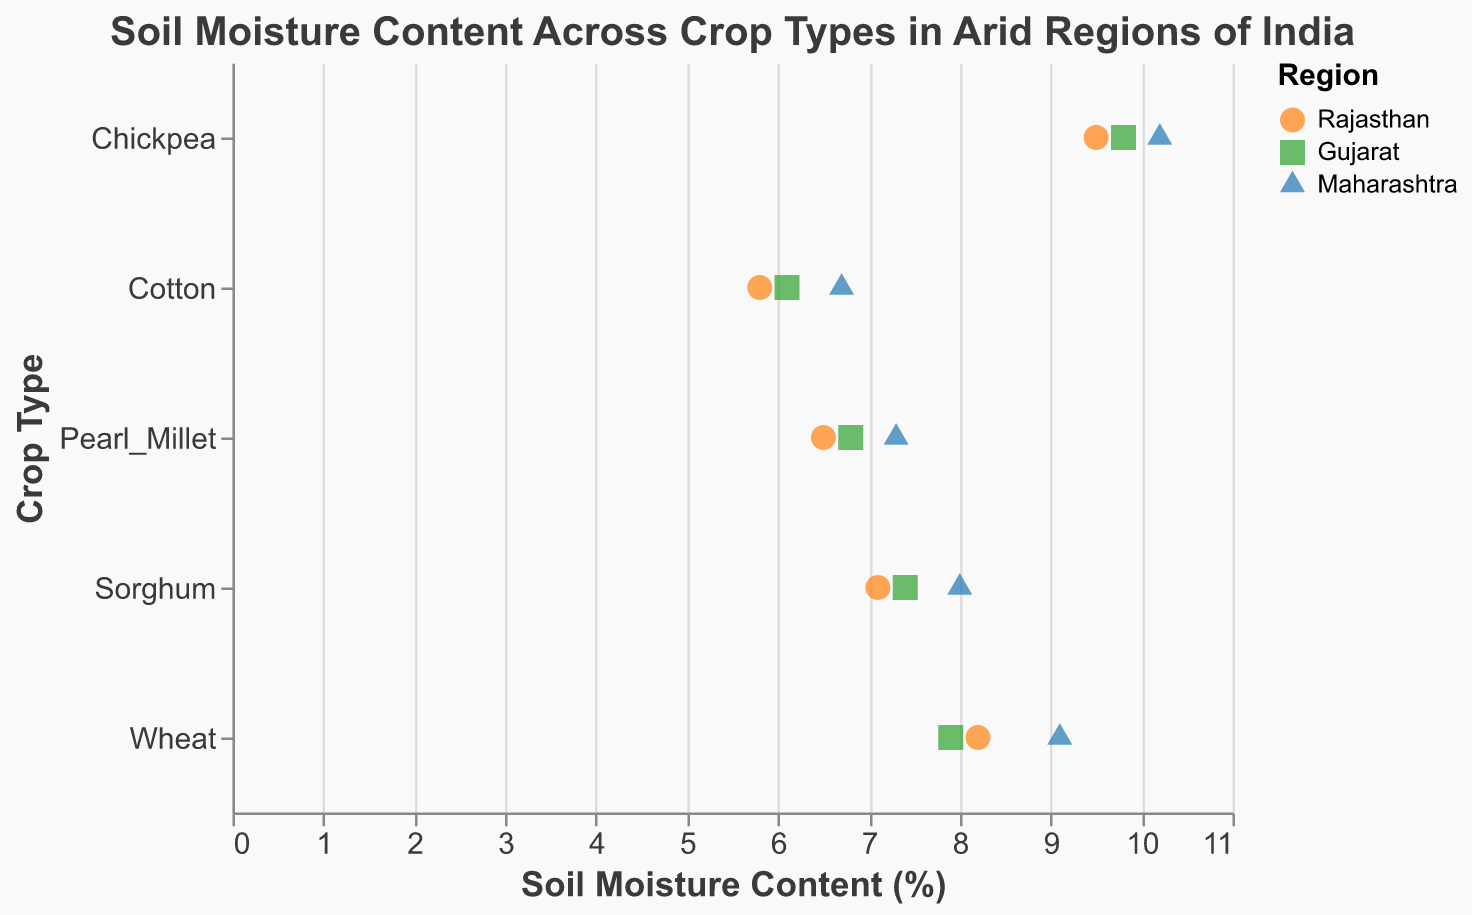What is the title of the plot? The title is typically located at the top of the figure, and it should be easy to read.
Answer: Soil Moisture Content Across Crop Types in Arid Regions of India Which crop type has the highest soil moisture content? By inspecting the x-axis values for each crop type, Chickpea has data points that go up to around 10.2%, which is the highest among all crops.
Answer: Chickpea What color is associated with the region of Gujarat? The legend in the plot shows the color associated with each region. For Gujarat, the color is green.
Answer: Green How many regions are represented in the plot? The legend and different colors/shapes used in the plot allow us to count the distinct regions. There are three regions represented: Rajasthan, Gujarat, and Maharashtra.
Answer: Three Which crop has the lowest soil moisture content in Rajasthan? By looking at the soil moisture content on the x-axis and identifying the points for Rajasthan (orange circles), we see that Cotton has the lowest value, around 5.8%.
Answer: Cotton What is the average soil moisture content of Sorghum across all regions? Add the soil moisture content values for Sorghum (7.1, 7.4, 8.0) and divide by the number of data points (3). So, (7.1 + 7.4 + 8.0) / 3 = 22.5 / 3 = 7.5.
Answer: 7.5 Which region shows the highest soil moisture content for Wheat? Identify the points for Wheat and compare the figures for Rajasthan (orange circle), Gujarat (green square), and Maharashtra (blue triangle). Wheat in Maharashtra has the highest value (9.1%).
Answer: Maharashtra Are there any crops that have similar soil moisture content across all three regions? By comparing the points for each crop type across the regions, Pearl Millet has relatively close values (6.5, 6.8, 7.3), showing consistency across different regions.
Answer: Pearl Millet Which region has the most diverse (highest range) soil moisture content values for Chickpea? Identify the soil moisture content for Chickpea across Rajasthan, Gujarat, and Maharashtra. The range is from 9.5 to 10.2 in Maharashtra, which shows the highest variation (10.2 - 9.8 = 0.4, the lowest variability).
Answer: Maharashtra 